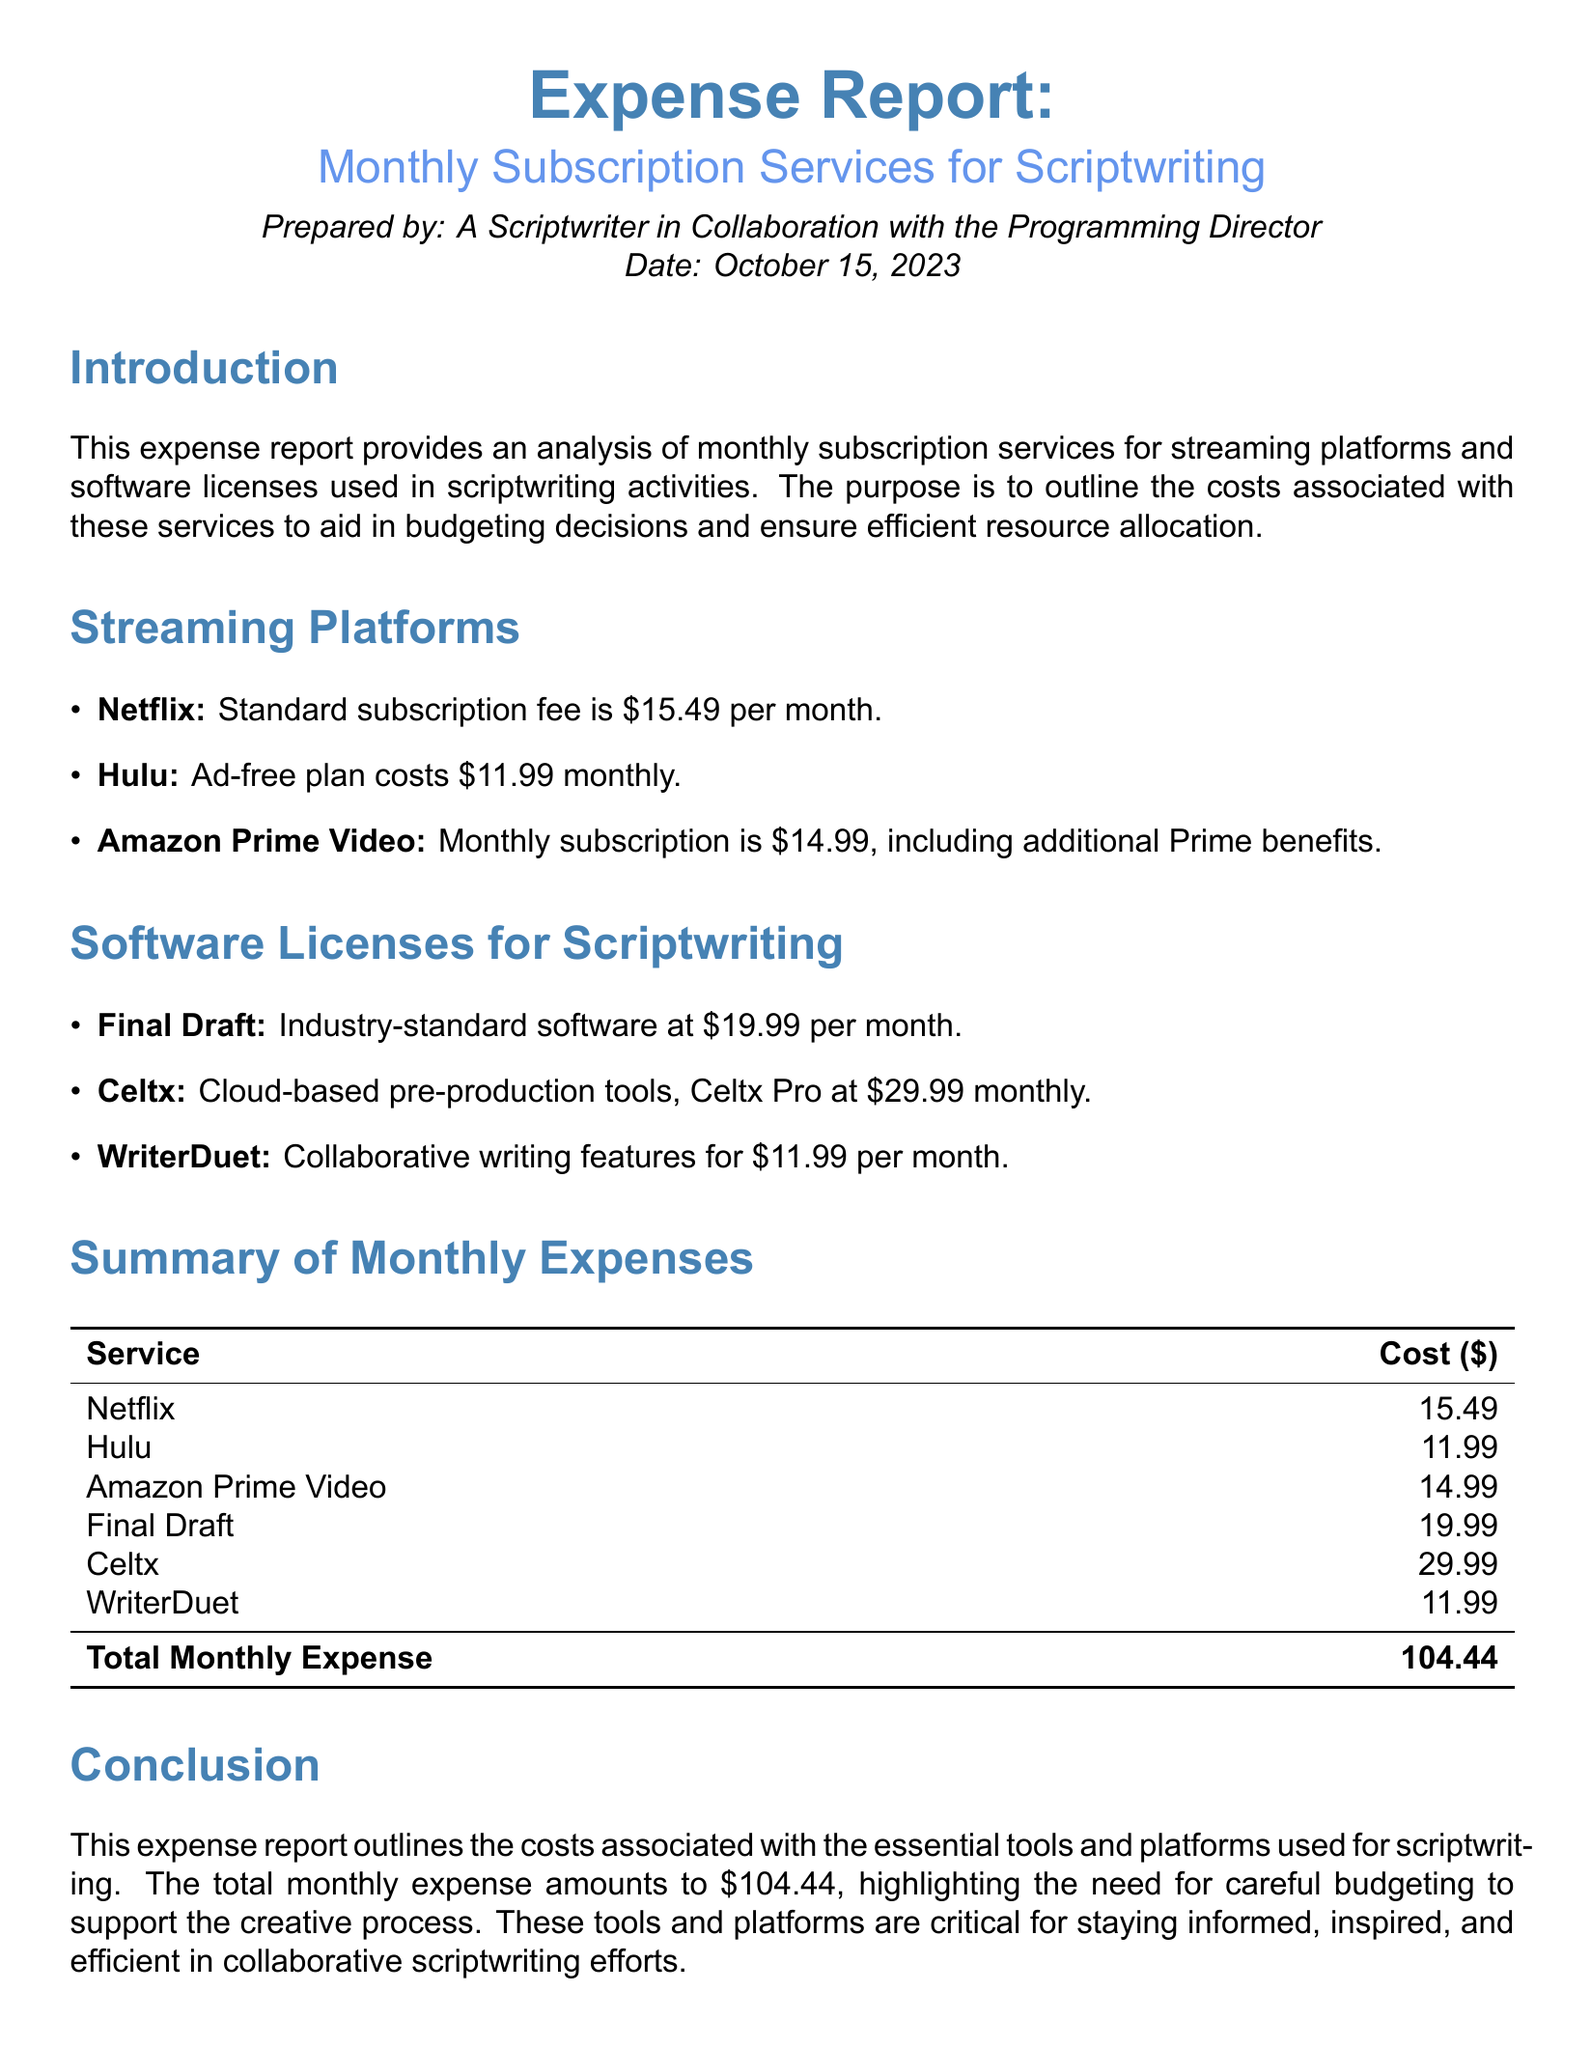what is the total monthly expense? The total monthly expense is calculated by summing the costs of all the listed services in the document.
Answer: 104.44 how much does a Netflix subscription cost? The document lists the cost of a Netflix subscription as part of the streaming platforms section.
Answer: 15.49 which software license is the most expensive? Comparing the listed costs of software licenses for scriptwriting, Celtx is the most expensive.
Answer: Celtx what is the monthly cost of WriterDuet? The document specifies the cost associated with WriterDuet in the software licenses section.
Answer: 11.99 who prepared this expense report? The document states the preparer of the report in the introductory section.
Answer: A Scriptwriter in Collaboration with the Programming Director how many streaming platforms are mentioned? The document lists the streaming platforms, and a count of these platforms gives the answer.
Answer: 3 which software is considered industry-standard? The document refers to Final Draft as industry-standard software for scriptwriting.
Answer: Final Draft what is the monthly cost of Hulu's ad-free plan? The document provides the specific cost for Hulu's ad-free plan under the streaming platforms section.
Answer: 11.99 what date was this expense report prepared? The document includes the preparation date in the introductory details.
Answer: October 15, 2023 